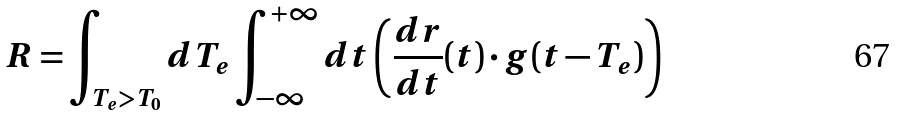<formula> <loc_0><loc_0><loc_500><loc_500>R = \int _ { T _ { e } > T _ { 0 } } d T _ { e } \int _ { - \infty } ^ { + \infty } d t \left ( \frac { d r } { d t } ( t ) \cdot g ( t - T _ { e } ) \right )</formula> 